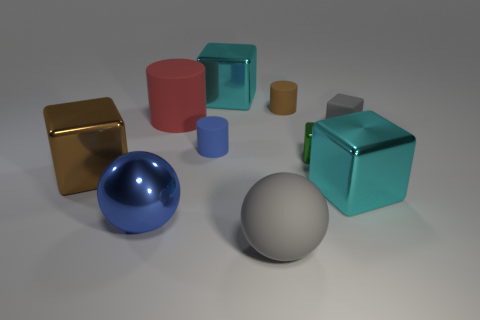Is the ball that is to the left of the blue cylinder made of the same material as the cylinder to the right of the small blue matte object?
Give a very brief answer. No. There is a blue thing that is the same shape as the brown matte object; what is its material?
Give a very brief answer. Rubber. There is a big cyan object that is in front of the large brown object; is its shape the same as the large metallic object behind the matte cube?
Offer a terse response. Yes. Is the number of small brown cylinders that are on the left side of the blue ball less than the number of small rubber cylinders behind the brown metal object?
Keep it short and to the point. Yes. What number of other objects are there of the same shape as the brown matte thing?
Offer a terse response. 2. What shape is the brown thing that is made of the same material as the big red thing?
Keep it short and to the point. Cylinder. The big block that is both on the left side of the small green block and to the right of the big cylinder is what color?
Keep it short and to the point. Cyan. Is the brown thing right of the blue shiny sphere made of the same material as the blue sphere?
Offer a terse response. No. Is the number of red rubber cylinders to the right of the small blue matte thing less than the number of matte blocks?
Your response must be concise. Yes. Is there a blue object that has the same material as the brown cylinder?
Keep it short and to the point. Yes. 